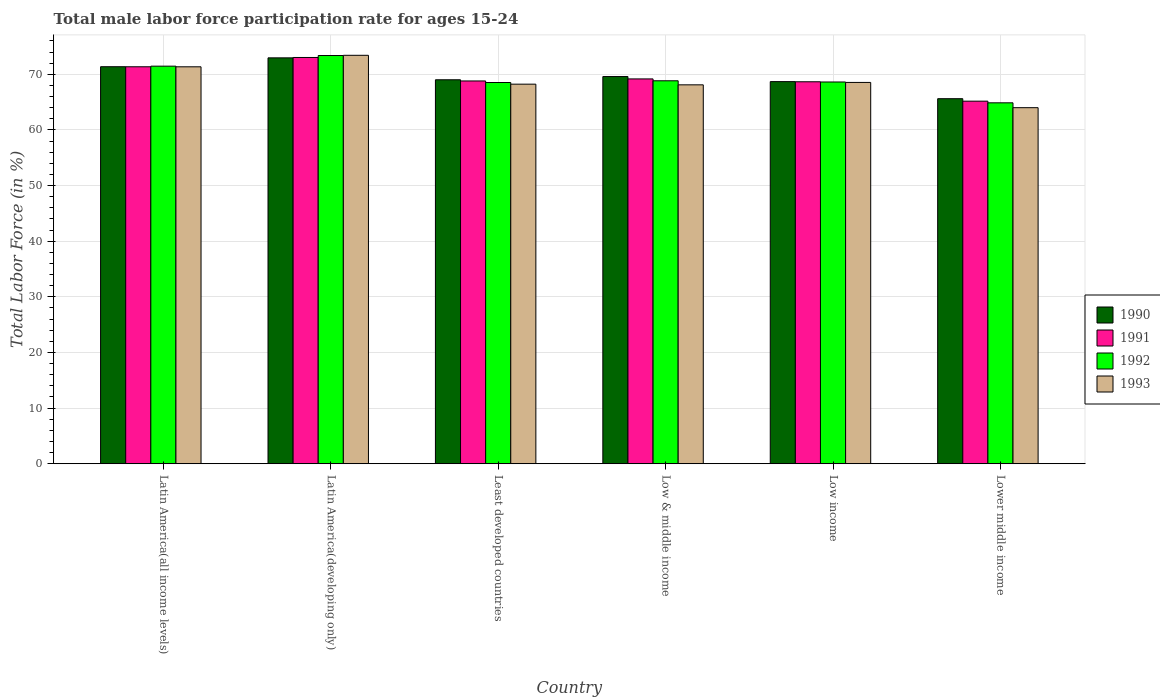How many groups of bars are there?
Give a very brief answer. 6. Are the number of bars per tick equal to the number of legend labels?
Keep it short and to the point. Yes. How many bars are there on the 4th tick from the right?
Your answer should be very brief. 4. In how many cases, is the number of bars for a given country not equal to the number of legend labels?
Your answer should be compact. 0. What is the male labor force participation rate in 1991 in Least developed countries?
Make the answer very short. 68.8. Across all countries, what is the maximum male labor force participation rate in 1993?
Ensure brevity in your answer.  73.42. Across all countries, what is the minimum male labor force participation rate in 1993?
Give a very brief answer. 64. In which country was the male labor force participation rate in 1992 maximum?
Keep it short and to the point. Latin America(developing only). In which country was the male labor force participation rate in 1992 minimum?
Make the answer very short. Lower middle income. What is the total male labor force participation rate in 1991 in the graph?
Offer a terse response. 416.18. What is the difference between the male labor force participation rate in 1993 in Latin America(developing only) and that in Low & middle income?
Make the answer very short. 5.31. What is the difference between the male labor force participation rate in 1991 in Low & middle income and the male labor force participation rate in 1992 in Latin America(developing only)?
Your answer should be compact. -4.21. What is the average male labor force participation rate in 1991 per country?
Keep it short and to the point. 69.36. What is the difference between the male labor force participation rate of/in 1992 and male labor force participation rate of/in 1993 in Least developed countries?
Your answer should be very brief. 0.3. What is the ratio of the male labor force participation rate in 1991 in Latin America(developing only) to that in Low income?
Provide a succinct answer. 1.06. What is the difference between the highest and the second highest male labor force participation rate in 1990?
Provide a short and direct response. 3.36. What is the difference between the highest and the lowest male labor force participation rate in 1990?
Offer a terse response. 7.34. Is the sum of the male labor force participation rate in 1993 in Latin America(all income levels) and Low & middle income greater than the maximum male labor force participation rate in 1990 across all countries?
Your answer should be compact. Yes. Is it the case that in every country, the sum of the male labor force participation rate in 1992 and male labor force participation rate in 1993 is greater than the sum of male labor force participation rate in 1990 and male labor force participation rate in 1991?
Provide a succinct answer. No. What does the 3rd bar from the left in Latin America(developing only) represents?
Your answer should be very brief. 1992. How many countries are there in the graph?
Your answer should be very brief. 6. What is the difference between two consecutive major ticks on the Y-axis?
Ensure brevity in your answer.  10. Does the graph contain any zero values?
Offer a terse response. No. Where does the legend appear in the graph?
Provide a short and direct response. Center right. What is the title of the graph?
Your answer should be compact. Total male labor force participation rate for ages 15-24. What is the label or title of the X-axis?
Your answer should be very brief. Country. What is the label or title of the Y-axis?
Make the answer very short. Total Labor Force (in %). What is the Total Labor Force (in %) in 1990 in Latin America(all income levels)?
Offer a very short reply. 71.36. What is the Total Labor Force (in %) in 1991 in Latin America(all income levels)?
Make the answer very short. 71.35. What is the Total Labor Force (in %) of 1992 in Latin America(all income levels)?
Keep it short and to the point. 71.46. What is the Total Labor Force (in %) in 1993 in Latin America(all income levels)?
Provide a succinct answer. 71.35. What is the Total Labor Force (in %) in 1990 in Latin America(developing only)?
Your response must be concise. 72.96. What is the Total Labor Force (in %) in 1991 in Latin America(developing only)?
Your answer should be compact. 73.02. What is the Total Labor Force (in %) in 1992 in Latin America(developing only)?
Your response must be concise. 73.38. What is the Total Labor Force (in %) in 1993 in Latin America(developing only)?
Give a very brief answer. 73.42. What is the Total Labor Force (in %) of 1990 in Least developed countries?
Your answer should be compact. 69.02. What is the Total Labor Force (in %) of 1991 in Least developed countries?
Ensure brevity in your answer.  68.8. What is the Total Labor Force (in %) in 1992 in Least developed countries?
Provide a short and direct response. 68.53. What is the Total Labor Force (in %) in 1993 in Least developed countries?
Your response must be concise. 68.23. What is the Total Labor Force (in %) of 1990 in Low & middle income?
Your answer should be compact. 69.59. What is the Total Labor Force (in %) in 1991 in Low & middle income?
Offer a terse response. 69.17. What is the Total Labor Force (in %) in 1992 in Low & middle income?
Provide a succinct answer. 68.83. What is the Total Labor Force (in %) in 1993 in Low & middle income?
Provide a short and direct response. 68.11. What is the Total Labor Force (in %) of 1990 in Low income?
Your response must be concise. 68.69. What is the Total Labor Force (in %) of 1991 in Low income?
Ensure brevity in your answer.  68.66. What is the Total Labor Force (in %) in 1992 in Low income?
Give a very brief answer. 68.62. What is the Total Labor Force (in %) of 1993 in Low income?
Offer a terse response. 68.54. What is the Total Labor Force (in %) in 1990 in Lower middle income?
Your answer should be compact. 65.62. What is the Total Labor Force (in %) in 1991 in Lower middle income?
Offer a terse response. 65.17. What is the Total Labor Force (in %) in 1992 in Lower middle income?
Provide a succinct answer. 64.87. What is the Total Labor Force (in %) in 1993 in Lower middle income?
Your response must be concise. 64. Across all countries, what is the maximum Total Labor Force (in %) in 1990?
Ensure brevity in your answer.  72.96. Across all countries, what is the maximum Total Labor Force (in %) of 1991?
Make the answer very short. 73.02. Across all countries, what is the maximum Total Labor Force (in %) in 1992?
Provide a succinct answer. 73.38. Across all countries, what is the maximum Total Labor Force (in %) in 1993?
Offer a very short reply. 73.42. Across all countries, what is the minimum Total Labor Force (in %) in 1990?
Offer a very short reply. 65.62. Across all countries, what is the minimum Total Labor Force (in %) of 1991?
Ensure brevity in your answer.  65.17. Across all countries, what is the minimum Total Labor Force (in %) of 1992?
Your answer should be compact. 64.87. Across all countries, what is the minimum Total Labor Force (in %) of 1993?
Your answer should be very brief. 64. What is the total Total Labor Force (in %) of 1990 in the graph?
Your answer should be very brief. 417.24. What is the total Total Labor Force (in %) of 1991 in the graph?
Your answer should be very brief. 416.18. What is the total Total Labor Force (in %) in 1992 in the graph?
Offer a very short reply. 415.69. What is the total Total Labor Force (in %) of 1993 in the graph?
Your response must be concise. 413.64. What is the difference between the Total Labor Force (in %) in 1990 in Latin America(all income levels) and that in Latin America(developing only)?
Your answer should be very brief. -1.59. What is the difference between the Total Labor Force (in %) of 1991 in Latin America(all income levels) and that in Latin America(developing only)?
Make the answer very short. -1.67. What is the difference between the Total Labor Force (in %) in 1992 in Latin America(all income levels) and that in Latin America(developing only)?
Make the answer very short. -1.91. What is the difference between the Total Labor Force (in %) of 1993 in Latin America(all income levels) and that in Latin America(developing only)?
Ensure brevity in your answer.  -2.07. What is the difference between the Total Labor Force (in %) in 1990 in Latin America(all income levels) and that in Least developed countries?
Ensure brevity in your answer.  2.35. What is the difference between the Total Labor Force (in %) of 1991 in Latin America(all income levels) and that in Least developed countries?
Your answer should be compact. 2.55. What is the difference between the Total Labor Force (in %) of 1992 in Latin America(all income levels) and that in Least developed countries?
Your answer should be compact. 2.94. What is the difference between the Total Labor Force (in %) in 1993 in Latin America(all income levels) and that in Least developed countries?
Provide a short and direct response. 3.12. What is the difference between the Total Labor Force (in %) of 1990 in Latin America(all income levels) and that in Low & middle income?
Your answer should be compact. 1.77. What is the difference between the Total Labor Force (in %) of 1991 in Latin America(all income levels) and that in Low & middle income?
Provide a succinct answer. 2.18. What is the difference between the Total Labor Force (in %) in 1992 in Latin America(all income levels) and that in Low & middle income?
Provide a succinct answer. 2.63. What is the difference between the Total Labor Force (in %) of 1993 in Latin America(all income levels) and that in Low & middle income?
Your answer should be compact. 3.24. What is the difference between the Total Labor Force (in %) of 1990 in Latin America(all income levels) and that in Low income?
Keep it short and to the point. 2.68. What is the difference between the Total Labor Force (in %) of 1991 in Latin America(all income levels) and that in Low income?
Give a very brief answer. 2.69. What is the difference between the Total Labor Force (in %) in 1992 in Latin America(all income levels) and that in Low income?
Your answer should be compact. 2.84. What is the difference between the Total Labor Force (in %) in 1993 in Latin America(all income levels) and that in Low income?
Make the answer very short. 2.81. What is the difference between the Total Labor Force (in %) in 1990 in Latin America(all income levels) and that in Lower middle income?
Offer a very short reply. 5.75. What is the difference between the Total Labor Force (in %) of 1991 in Latin America(all income levels) and that in Lower middle income?
Your answer should be compact. 6.18. What is the difference between the Total Labor Force (in %) of 1992 in Latin America(all income levels) and that in Lower middle income?
Your answer should be compact. 6.59. What is the difference between the Total Labor Force (in %) of 1993 in Latin America(all income levels) and that in Lower middle income?
Keep it short and to the point. 7.35. What is the difference between the Total Labor Force (in %) in 1990 in Latin America(developing only) and that in Least developed countries?
Your response must be concise. 3.94. What is the difference between the Total Labor Force (in %) in 1991 in Latin America(developing only) and that in Least developed countries?
Provide a succinct answer. 4.22. What is the difference between the Total Labor Force (in %) of 1992 in Latin America(developing only) and that in Least developed countries?
Offer a very short reply. 4.85. What is the difference between the Total Labor Force (in %) in 1993 in Latin America(developing only) and that in Least developed countries?
Your answer should be very brief. 5.19. What is the difference between the Total Labor Force (in %) in 1990 in Latin America(developing only) and that in Low & middle income?
Offer a terse response. 3.36. What is the difference between the Total Labor Force (in %) of 1991 in Latin America(developing only) and that in Low & middle income?
Your response must be concise. 3.85. What is the difference between the Total Labor Force (in %) of 1992 in Latin America(developing only) and that in Low & middle income?
Offer a very short reply. 4.54. What is the difference between the Total Labor Force (in %) of 1993 in Latin America(developing only) and that in Low & middle income?
Provide a short and direct response. 5.31. What is the difference between the Total Labor Force (in %) of 1990 in Latin America(developing only) and that in Low income?
Provide a short and direct response. 4.27. What is the difference between the Total Labor Force (in %) in 1991 in Latin America(developing only) and that in Low income?
Ensure brevity in your answer.  4.37. What is the difference between the Total Labor Force (in %) of 1992 in Latin America(developing only) and that in Low income?
Provide a short and direct response. 4.76. What is the difference between the Total Labor Force (in %) in 1993 in Latin America(developing only) and that in Low income?
Your response must be concise. 4.88. What is the difference between the Total Labor Force (in %) in 1990 in Latin America(developing only) and that in Lower middle income?
Give a very brief answer. 7.34. What is the difference between the Total Labor Force (in %) of 1991 in Latin America(developing only) and that in Lower middle income?
Your response must be concise. 7.85. What is the difference between the Total Labor Force (in %) in 1992 in Latin America(developing only) and that in Lower middle income?
Give a very brief answer. 8.5. What is the difference between the Total Labor Force (in %) in 1993 in Latin America(developing only) and that in Lower middle income?
Your answer should be compact. 9.42. What is the difference between the Total Labor Force (in %) of 1990 in Least developed countries and that in Low & middle income?
Make the answer very short. -0.58. What is the difference between the Total Labor Force (in %) of 1991 in Least developed countries and that in Low & middle income?
Make the answer very short. -0.37. What is the difference between the Total Labor Force (in %) in 1992 in Least developed countries and that in Low & middle income?
Offer a very short reply. -0.31. What is the difference between the Total Labor Force (in %) in 1993 in Least developed countries and that in Low & middle income?
Ensure brevity in your answer.  0.12. What is the difference between the Total Labor Force (in %) in 1990 in Least developed countries and that in Low income?
Provide a succinct answer. 0.33. What is the difference between the Total Labor Force (in %) of 1991 in Least developed countries and that in Low income?
Your answer should be very brief. 0.14. What is the difference between the Total Labor Force (in %) in 1992 in Least developed countries and that in Low income?
Provide a short and direct response. -0.09. What is the difference between the Total Labor Force (in %) of 1993 in Least developed countries and that in Low income?
Provide a short and direct response. -0.31. What is the difference between the Total Labor Force (in %) in 1990 in Least developed countries and that in Lower middle income?
Offer a terse response. 3.4. What is the difference between the Total Labor Force (in %) in 1991 in Least developed countries and that in Lower middle income?
Your answer should be compact. 3.63. What is the difference between the Total Labor Force (in %) of 1992 in Least developed countries and that in Lower middle income?
Provide a short and direct response. 3.65. What is the difference between the Total Labor Force (in %) in 1993 in Least developed countries and that in Lower middle income?
Offer a very short reply. 4.23. What is the difference between the Total Labor Force (in %) of 1990 in Low & middle income and that in Low income?
Your response must be concise. 0.91. What is the difference between the Total Labor Force (in %) in 1991 in Low & middle income and that in Low income?
Give a very brief answer. 0.51. What is the difference between the Total Labor Force (in %) of 1992 in Low & middle income and that in Low income?
Make the answer very short. 0.22. What is the difference between the Total Labor Force (in %) of 1993 in Low & middle income and that in Low income?
Your response must be concise. -0.43. What is the difference between the Total Labor Force (in %) of 1990 in Low & middle income and that in Lower middle income?
Your response must be concise. 3.98. What is the difference between the Total Labor Force (in %) in 1991 in Low & middle income and that in Lower middle income?
Make the answer very short. 4. What is the difference between the Total Labor Force (in %) of 1992 in Low & middle income and that in Lower middle income?
Offer a very short reply. 3.96. What is the difference between the Total Labor Force (in %) in 1993 in Low & middle income and that in Lower middle income?
Offer a very short reply. 4.11. What is the difference between the Total Labor Force (in %) of 1990 in Low income and that in Lower middle income?
Offer a very short reply. 3.07. What is the difference between the Total Labor Force (in %) of 1991 in Low income and that in Lower middle income?
Your answer should be very brief. 3.49. What is the difference between the Total Labor Force (in %) in 1992 in Low income and that in Lower middle income?
Give a very brief answer. 3.74. What is the difference between the Total Labor Force (in %) of 1993 in Low income and that in Lower middle income?
Offer a terse response. 4.54. What is the difference between the Total Labor Force (in %) of 1990 in Latin America(all income levels) and the Total Labor Force (in %) of 1991 in Latin America(developing only)?
Your answer should be compact. -1.66. What is the difference between the Total Labor Force (in %) in 1990 in Latin America(all income levels) and the Total Labor Force (in %) in 1992 in Latin America(developing only)?
Provide a short and direct response. -2.01. What is the difference between the Total Labor Force (in %) in 1990 in Latin America(all income levels) and the Total Labor Force (in %) in 1993 in Latin America(developing only)?
Give a very brief answer. -2.05. What is the difference between the Total Labor Force (in %) in 1991 in Latin America(all income levels) and the Total Labor Force (in %) in 1992 in Latin America(developing only)?
Your answer should be very brief. -2.02. What is the difference between the Total Labor Force (in %) in 1991 in Latin America(all income levels) and the Total Labor Force (in %) in 1993 in Latin America(developing only)?
Keep it short and to the point. -2.06. What is the difference between the Total Labor Force (in %) of 1992 in Latin America(all income levels) and the Total Labor Force (in %) of 1993 in Latin America(developing only)?
Give a very brief answer. -1.95. What is the difference between the Total Labor Force (in %) in 1990 in Latin America(all income levels) and the Total Labor Force (in %) in 1991 in Least developed countries?
Provide a short and direct response. 2.56. What is the difference between the Total Labor Force (in %) in 1990 in Latin America(all income levels) and the Total Labor Force (in %) in 1992 in Least developed countries?
Your answer should be compact. 2.84. What is the difference between the Total Labor Force (in %) in 1990 in Latin America(all income levels) and the Total Labor Force (in %) in 1993 in Least developed countries?
Your response must be concise. 3.14. What is the difference between the Total Labor Force (in %) in 1991 in Latin America(all income levels) and the Total Labor Force (in %) in 1992 in Least developed countries?
Provide a short and direct response. 2.83. What is the difference between the Total Labor Force (in %) in 1991 in Latin America(all income levels) and the Total Labor Force (in %) in 1993 in Least developed countries?
Provide a succinct answer. 3.12. What is the difference between the Total Labor Force (in %) in 1992 in Latin America(all income levels) and the Total Labor Force (in %) in 1993 in Least developed countries?
Keep it short and to the point. 3.23. What is the difference between the Total Labor Force (in %) in 1990 in Latin America(all income levels) and the Total Labor Force (in %) in 1991 in Low & middle income?
Offer a terse response. 2.19. What is the difference between the Total Labor Force (in %) in 1990 in Latin America(all income levels) and the Total Labor Force (in %) in 1992 in Low & middle income?
Provide a succinct answer. 2.53. What is the difference between the Total Labor Force (in %) of 1990 in Latin America(all income levels) and the Total Labor Force (in %) of 1993 in Low & middle income?
Your answer should be compact. 3.26. What is the difference between the Total Labor Force (in %) in 1991 in Latin America(all income levels) and the Total Labor Force (in %) in 1992 in Low & middle income?
Your answer should be compact. 2.52. What is the difference between the Total Labor Force (in %) in 1991 in Latin America(all income levels) and the Total Labor Force (in %) in 1993 in Low & middle income?
Make the answer very short. 3.25. What is the difference between the Total Labor Force (in %) in 1992 in Latin America(all income levels) and the Total Labor Force (in %) in 1993 in Low & middle income?
Your answer should be compact. 3.36. What is the difference between the Total Labor Force (in %) in 1990 in Latin America(all income levels) and the Total Labor Force (in %) in 1991 in Low income?
Your response must be concise. 2.71. What is the difference between the Total Labor Force (in %) in 1990 in Latin America(all income levels) and the Total Labor Force (in %) in 1992 in Low income?
Offer a very short reply. 2.75. What is the difference between the Total Labor Force (in %) in 1990 in Latin America(all income levels) and the Total Labor Force (in %) in 1993 in Low income?
Your response must be concise. 2.82. What is the difference between the Total Labor Force (in %) of 1991 in Latin America(all income levels) and the Total Labor Force (in %) of 1992 in Low income?
Keep it short and to the point. 2.73. What is the difference between the Total Labor Force (in %) in 1991 in Latin America(all income levels) and the Total Labor Force (in %) in 1993 in Low income?
Your answer should be compact. 2.81. What is the difference between the Total Labor Force (in %) in 1992 in Latin America(all income levels) and the Total Labor Force (in %) in 1993 in Low income?
Make the answer very short. 2.92. What is the difference between the Total Labor Force (in %) in 1990 in Latin America(all income levels) and the Total Labor Force (in %) in 1991 in Lower middle income?
Your answer should be very brief. 6.19. What is the difference between the Total Labor Force (in %) in 1990 in Latin America(all income levels) and the Total Labor Force (in %) in 1992 in Lower middle income?
Make the answer very short. 6.49. What is the difference between the Total Labor Force (in %) of 1990 in Latin America(all income levels) and the Total Labor Force (in %) of 1993 in Lower middle income?
Your answer should be compact. 7.36. What is the difference between the Total Labor Force (in %) in 1991 in Latin America(all income levels) and the Total Labor Force (in %) in 1992 in Lower middle income?
Ensure brevity in your answer.  6.48. What is the difference between the Total Labor Force (in %) of 1991 in Latin America(all income levels) and the Total Labor Force (in %) of 1993 in Lower middle income?
Give a very brief answer. 7.35. What is the difference between the Total Labor Force (in %) of 1992 in Latin America(all income levels) and the Total Labor Force (in %) of 1993 in Lower middle income?
Your answer should be compact. 7.46. What is the difference between the Total Labor Force (in %) of 1990 in Latin America(developing only) and the Total Labor Force (in %) of 1991 in Least developed countries?
Offer a very short reply. 4.15. What is the difference between the Total Labor Force (in %) of 1990 in Latin America(developing only) and the Total Labor Force (in %) of 1992 in Least developed countries?
Give a very brief answer. 4.43. What is the difference between the Total Labor Force (in %) of 1990 in Latin America(developing only) and the Total Labor Force (in %) of 1993 in Least developed countries?
Offer a very short reply. 4.73. What is the difference between the Total Labor Force (in %) in 1991 in Latin America(developing only) and the Total Labor Force (in %) in 1992 in Least developed countries?
Your response must be concise. 4.5. What is the difference between the Total Labor Force (in %) of 1991 in Latin America(developing only) and the Total Labor Force (in %) of 1993 in Least developed countries?
Provide a succinct answer. 4.8. What is the difference between the Total Labor Force (in %) of 1992 in Latin America(developing only) and the Total Labor Force (in %) of 1993 in Least developed countries?
Offer a very short reply. 5.15. What is the difference between the Total Labor Force (in %) of 1990 in Latin America(developing only) and the Total Labor Force (in %) of 1991 in Low & middle income?
Ensure brevity in your answer.  3.79. What is the difference between the Total Labor Force (in %) of 1990 in Latin America(developing only) and the Total Labor Force (in %) of 1992 in Low & middle income?
Ensure brevity in your answer.  4.12. What is the difference between the Total Labor Force (in %) in 1990 in Latin America(developing only) and the Total Labor Force (in %) in 1993 in Low & middle income?
Give a very brief answer. 4.85. What is the difference between the Total Labor Force (in %) of 1991 in Latin America(developing only) and the Total Labor Force (in %) of 1992 in Low & middle income?
Provide a short and direct response. 4.19. What is the difference between the Total Labor Force (in %) of 1991 in Latin America(developing only) and the Total Labor Force (in %) of 1993 in Low & middle income?
Offer a terse response. 4.92. What is the difference between the Total Labor Force (in %) of 1992 in Latin America(developing only) and the Total Labor Force (in %) of 1993 in Low & middle income?
Provide a succinct answer. 5.27. What is the difference between the Total Labor Force (in %) in 1990 in Latin America(developing only) and the Total Labor Force (in %) in 1991 in Low income?
Your answer should be compact. 4.3. What is the difference between the Total Labor Force (in %) of 1990 in Latin America(developing only) and the Total Labor Force (in %) of 1992 in Low income?
Offer a terse response. 4.34. What is the difference between the Total Labor Force (in %) in 1990 in Latin America(developing only) and the Total Labor Force (in %) in 1993 in Low income?
Make the answer very short. 4.42. What is the difference between the Total Labor Force (in %) in 1991 in Latin America(developing only) and the Total Labor Force (in %) in 1992 in Low income?
Give a very brief answer. 4.4. What is the difference between the Total Labor Force (in %) of 1991 in Latin America(developing only) and the Total Labor Force (in %) of 1993 in Low income?
Your answer should be compact. 4.48. What is the difference between the Total Labor Force (in %) in 1992 in Latin America(developing only) and the Total Labor Force (in %) in 1993 in Low income?
Your answer should be very brief. 4.83. What is the difference between the Total Labor Force (in %) in 1990 in Latin America(developing only) and the Total Labor Force (in %) in 1991 in Lower middle income?
Ensure brevity in your answer.  7.79. What is the difference between the Total Labor Force (in %) of 1990 in Latin America(developing only) and the Total Labor Force (in %) of 1992 in Lower middle income?
Offer a very short reply. 8.08. What is the difference between the Total Labor Force (in %) in 1990 in Latin America(developing only) and the Total Labor Force (in %) in 1993 in Lower middle income?
Your answer should be very brief. 8.96. What is the difference between the Total Labor Force (in %) in 1991 in Latin America(developing only) and the Total Labor Force (in %) in 1992 in Lower middle income?
Make the answer very short. 8.15. What is the difference between the Total Labor Force (in %) of 1991 in Latin America(developing only) and the Total Labor Force (in %) of 1993 in Lower middle income?
Your answer should be compact. 9.02. What is the difference between the Total Labor Force (in %) of 1992 in Latin America(developing only) and the Total Labor Force (in %) of 1993 in Lower middle income?
Provide a succinct answer. 9.37. What is the difference between the Total Labor Force (in %) in 1990 in Least developed countries and the Total Labor Force (in %) in 1991 in Low & middle income?
Offer a very short reply. -0.15. What is the difference between the Total Labor Force (in %) of 1990 in Least developed countries and the Total Labor Force (in %) of 1992 in Low & middle income?
Keep it short and to the point. 0.18. What is the difference between the Total Labor Force (in %) in 1990 in Least developed countries and the Total Labor Force (in %) in 1993 in Low & middle income?
Ensure brevity in your answer.  0.91. What is the difference between the Total Labor Force (in %) of 1991 in Least developed countries and the Total Labor Force (in %) of 1992 in Low & middle income?
Ensure brevity in your answer.  -0.03. What is the difference between the Total Labor Force (in %) in 1991 in Least developed countries and the Total Labor Force (in %) in 1993 in Low & middle income?
Keep it short and to the point. 0.7. What is the difference between the Total Labor Force (in %) of 1992 in Least developed countries and the Total Labor Force (in %) of 1993 in Low & middle income?
Offer a very short reply. 0.42. What is the difference between the Total Labor Force (in %) of 1990 in Least developed countries and the Total Labor Force (in %) of 1991 in Low income?
Give a very brief answer. 0.36. What is the difference between the Total Labor Force (in %) in 1990 in Least developed countries and the Total Labor Force (in %) in 1992 in Low income?
Provide a short and direct response. 0.4. What is the difference between the Total Labor Force (in %) of 1990 in Least developed countries and the Total Labor Force (in %) of 1993 in Low income?
Keep it short and to the point. 0.48. What is the difference between the Total Labor Force (in %) in 1991 in Least developed countries and the Total Labor Force (in %) in 1992 in Low income?
Give a very brief answer. 0.18. What is the difference between the Total Labor Force (in %) of 1991 in Least developed countries and the Total Labor Force (in %) of 1993 in Low income?
Offer a very short reply. 0.26. What is the difference between the Total Labor Force (in %) of 1992 in Least developed countries and the Total Labor Force (in %) of 1993 in Low income?
Keep it short and to the point. -0.01. What is the difference between the Total Labor Force (in %) in 1990 in Least developed countries and the Total Labor Force (in %) in 1991 in Lower middle income?
Offer a terse response. 3.85. What is the difference between the Total Labor Force (in %) in 1990 in Least developed countries and the Total Labor Force (in %) in 1992 in Lower middle income?
Give a very brief answer. 4.14. What is the difference between the Total Labor Force (in %) of 1990 in Least developed countries and the Total Labor Force (in %) of 1993 in Lower middle income?
Your response must be concise. 5.02. What is the difference between the Total Labor Force (in %) of 1991 in Least developed countries and the Total Labor Force (in %) of 1992 in Lower middle income?
Provide a succinct answer. 3.93. What is the difference between the Total Labor Force (in %) in 1991 in Least developed countries and the Total Labor Force (in %) in 1993 in Lower middle income?
Your answer should be compact. 4.8. What is the difference between the Total Labor Force (in %) in 1992 in Least developed countries and the Total Labor Force (in %) in 1993 in Lower middle income?
Your answer should be compact. 4.53. What is the difference between the Total Labor Force (in %) in 1990 in Low & middle income and the Total Labor Force (in %) in 1991 in Low income?
Your answer should be very brief. 0.94. What is the difference between the Total Labor Force (in %) in 1990 in Low & middle income and the Total Labor Force (in %) in 1992 in Low income?
Give a very brief answer. 0.98. What is the difference between the Total Labor Force (in %) in 1990 in Low & middle income and the Total Labor Force (in %) in 1993 in Low income?
Ensure brevity in your answer.  1.05. What is the difference between the Total Labor Force (in %) of 1991 in Low & middle income and the Total Labor Force (in %) of 1992 in Low income?
Provide a short and direct response. 0.55. What is the difference between the Total Labor Force (in %) of 1991 in Low & middle income and the Total Labor Force (in %) of 1993 in Low income?
Provide a succinct answer. 0.63. What is the difference between the Total Labor Force (in %) of 1992 in Low & middle income and the Total Labor Force (in %) of 1993 in Low income?
Provide a short and direct response. 0.29. What is the difference between the Total Labor Force (in %) in 1990 in Low & middle income and the Total Labor Force (in %) in 1991 in Lower middle income?
Your answer should be very brief. 4.42. What is the difference between the Total Labor Force (in %) of 1990 in Low & middle income and the Total Labor Force (in %) of 1992 in Lower middle income?
Your answer should be very brief. 4.72. What is the difference between the Total Labor Force (in %) of 1990 in Low & middle income and the Total Labor Force (in %) of 1993 in Lower middle income?
Your answer should be compact. 5.59. What is the difference between the Total Labor Force (in %) of 1991 in Low & middle income and the Total Labor Force (in %) of 1992 in Lower middle income?
Make the answer very short. 4.3. What is the difference between the Total Labor Force (in %) of 1991 in Low & middle income and the Total Labor Force (in %) of 1993 in Lower middle income?
Offer a terse response. 5.17. What is the difference between the Total Labor Force (in %) in 1992 in Low & middle income and the Total Labor Force (in %) in 1993 in Lower middle income?
Your response must be concise. 4.83. What is the difference between the Total Labor Force (in %) of 1990 in Low income and the Total Labor Force (in %) of 1991 in Lower middle income?
Keep it short and to the point. 3.51. What is the difference between the Total Labor Force (in %) in 1990 in Low income and the Total Labor Force (in %) in 1992 in Lower middle income?
Provide a succinct answer. 3.81. What is the difference between the Total Labor Force (in %) in 1990 in Low income and the Total Labor Force (in %) in 1993 in Lower middle income?
Your answer should be very brief. 4.68. What is the difference between the Total Labor Force (in %) in 1991 in Low income and the Total Labor Force (in %) in 1992 in Lower middle income?
Give a very brief answer. 3.78. What is the difference between the Total Labor Force (in %) of 1991 in Low income and the Total Labor Force (in %) of 1993 in Lower middle income?
Ensure brevity in your answer.  4.66. What is the difference between the Total Labor Force (in %) in 1992 in Low income and the Total Labor Force (in %) in 1993 in Lower middle income?
Ensure brevity in your answer.  4.62. What is the average Total Labor Force (in %) of 1990 per country?
Make the answer very short. 69.54. What is the average Total Labor Force (in %) of 1991 per country?
Your answer should be compact. 69.36. What is the average Total Labor Force (in %) in 1992 per country?
Provide a short and direct response. 69.28. What is the average Total Labor Force (in %) in 1993 per country?
Provide a succinct answer. 68.94. What is the difference between the Total Labor Force (in %) of 1990 and Total Labor Force (in %) of 1991 in Latin America(all income levels)?
Provide a short and direct response. 0.01. What is the difference between the Total Labor Force (in %) of 1990 and Total Labor Force (in %) of 1992 in Latin America(all income levels)?
Your answer should be very brief. -0.1. What is the difference between the Total Labor Force (in %) of 1990 and Total Labor Force (in %) of 1993 in Latin America(all income levels)?
Offer a very short reply. 0.02. What is the difference between the Total Labor Force (in %) of 1991 and Total Labor Force (in %) of 1992 in Latin America(all income levels)?
Offer a very short reply. -0.11. What is the difference between the Total Labor Force (in %) of 1991 and Total Labor Force (in %) of 1993 in Latin America(all income levels)?
Your answer should be very brief. 0. What is the difference between the Total Labor Force (in %) in 1992 and Total Labor Force (in %) in 1993 in Latin America(all income levels)?
Provide a short and direct response. 0.11. What is the difference between the Total Labor Force (in %) of 1990 and Total Labor Force (in %) of 1991 in Latin America(developing only)?
Your answer should be compact. -0.07. What is the difference between the Total Labor Force (in %) of 1990 and Total Labor Force (in %) of 1992 in Latin America(developing only)?
Your response must be concise. -0.42. What is the difference between the Total Labor Force (in %) of 1990 and Total Labor Force (in %) of 1993 in Latin America(developing only)?
Offer a terse response. -0.46. What is the difference between the Total Labor Force (in %) of 1991 and Total Labor Force (in %) of 1992 in Latin America(developing only)?
Provide a short and direct response. -0.35. What is the difference between the Total Labor Force (in %) of 1991 and Total Labor Force (in %) of 1993 in Latin America(developing only)?
Give a very brief answer. -0.39. What is the difference between the Total Labor Force (in %) in 1992 and Total Labor Force (in %) in 1993 in Latin America(developing only)?
Make the answer very short. -0.04. What is the difference between the Total Labor Force (in %) in 1990 and Total Labor Force (in %) in 1991 in Least developed countries?
Give a very brief answer. 0.21. What is the difference between the Total Labor Force (in %) in 1990 and Total Labor Force (in %) in 1992 in Least developed countries?
Ensure brevity in your answer.  0.49. What is the difference between the Total Labor Force (in %) in 1990 and Total Labor Force (in %) in 1993 in Least developed countries?
Offer a terse response. 0.79. What is the difference between the Total Labor Force (in %) in 1991 and Total Labor Force (in %) in 1992 in Least developed countries?
Make the answer very short. 0.28. What is the difference between the Total Labor Force (in %) of 1991 and Total Labor Force (in %) of 1993 in Least developed countries?
Keep it short and to the point. 0.57. What is the difference between the Total Labor Force (in %) in 1992 and Total Labor Force (in %) in 1993 in Least developed countries?
Your answer should be compact. 0.3. What is the difference between the Total Labor Force (in %) of 1990 and Total Labor Force (in %) of 1991 in Low & middle income?
Offer a very short reply. 0.42. What is the difference between the Total Labor Force (in %) of 1990 and Total Labor Force (in %) of 1992 in Low & middle income?
Give a very brief answer. 0.76. What is the difference between the Total Labor Force (in %) in 1990 and Total Labor Force (in %) in 1993 in Low & middle income?
Keep it short and to the point. 1.49. What is the difference between the Total Labor Force (in %) of 1991 and Total Labor Force (in %) of 1992 in Low & middle income?
Your response must be concise. 0.34. What is the difference between the Total Labor Force (in %) in 1991 and Total Labor Force (in %) in 1993 in Low & middle income?
Give a very brief answer. 1.06. What is the difference between the Total Labor Force (in %) in 1992 and Total Labor Force (in %) in 1993 in Low & middle income?
Make the answer very short. 0.73. What is the difference between the Total Labor Force (in %) in 1990 and Total Labor Force (in %) in 1991 in Low income?
Ensure brevity in your answer.  0.03. What is the difference between the Total Labor Force (in %) of 1990 and Total Labor Force (in %) of 1992 in Low income?
Make the answer very short. 0.07. What is the difference between the Total Labor Force (in %) in 1990 and Total Labor Force (in %) in 1993 in Low income?
Your response must be concise. 0.14. What is the difference between the Total Labor Force (in %) in 1991 and Total Labor Force (in %) in 1992 in Low income?
Provide a short and direct response. 0.04. What is the difference between the Total Labor Force (in %) of 1991 and Total Labor Force (in %) of 1993 in Low income?
Provide a succinct answer. 0.12. What is the difference between the Total Labor Force (in %) in 1992 and Total Labor Force (in %) in 1993 in Low income?
Provide a short and direct response. 0.08. What is the difference between the Total Labor Force (in %) of 1990 and Total Labor Force (in %) of 1991 in Lower middle income?
Provide a short and direct response. 0.45. What is the difference between the Total Labor Force (in %) of 1990 and Total Labor Force (in %) of 1992 in Lower middle income?
Give a very brief answer. 0.74. What is the difference between the Total Labor Force (in %) in 1990 and Total Labor Force (in %) in 1993 in Lower middle income?
Offer a terse response. 1.62. What is the difference between the Total Labor Force (in %) of 1991 and Total Labor Force (in %) of 1992 in Lower middle income?
Provide a succinct answer. 0.3. What is the difference between the Total Labor Force (in %) of 1991 and Total Labor Force (in %) of 1993 in Lower middle income?
Ensure brevity in your answer.  1.17. What is the difference between the Total Labor Force (in %) in 1992 and Total Labor Force (in %) in 1993 in Lower middle income?
Provide a succinct answer. 0.87. What is the ratio of the Total Labor Force (in %) of 1990 in Latin America(all income levels) to that in Latin America(developing only)?
Offer a very short reply. 0.98. What is the ratio of the Total Labor Force (in %) of 1991 in Latin America(all income levels) to that in Latin America(developing only)?
Offer a terse response. 0.98. What is the ratio of the Total Labor Force (in %) of 1992 in Latin America(all income levels) to that in Latin America(developing only)?
Provide a succinct answer. 0.97. What is the ratio of the Total Labor Force (in %) of 1993 in Latin America(all income levels) to that in Latin America(developing only)?
Provide a short and direct response. 0.97. What is the ratio of the Total Labor Force (in %) of 1990 in Latin America(all income levels) to that in Least developed countries?
Provide a short and direct response. 1.03. What is the ratio of the Total Labor Force (in %) of 1991 in Latin America(all income levels) to that in Least developed countries?
Ensure brevity in your answer.  1.04. What is the ratio of the Total Labor Force (in %) of 1992 in Latin America(all income levels) to that in Least developed countries?
Ensure brevity in your answer.  1.04. What is the ratio of the Total Labor Force (in %) of 1993 in Latin America(all income levels) to that in Least developed countries?
Offer a very short reply. 1.05. What is the ratio of the Total Labor Force (in %) of 1990 in Latin America(all income levels) to that in Low & middle income?
Offer a terse response. 1.03. What is the ratio of the Total Labor Force (in %) in 1991 in Latin America(all income levels) to that in Low & middle income?
Provide a short and direct response. 1.03. What is the ratio of the Total Labor Force (in %) in 1992 in Latin America(all income levels) to that in Low & middle income?
Ensure brevity in your answer.  1.04. What is the ratio of the Total Labor Force (in %) of 1993 in Latin America(all income levels) to that in Low & middle income?
Keep it short and to the point. 1.05. What is the ratio of the Total Labor Force (in %) in 1990 in Latin America(all income levels) to that in Low income?
Provide a succinct answer. 1.04. What is the ratio of the Total Labor Force (in %) of 1991 in Latin America(all income levels) to that in Low income?
Give a very brief answer. 1.04. What is the ratio of the Total Labor Force (in %) in 1992 in Latin America(all income levels) to that in Low income?
Offer a terse response. 1.04. What is the ratio of the Total Labor Force (in %) in 1993 in Latin America(all income levels) to that in Low income?
Your answer should be very brief. 1.04. What is the ratio of the Total Labor Force (in %) in 1990 in Latin America(all income levels) to that in Lower middle income?
Your response must be concise. 1.09. What is the ratio of the Total Labor Force (in %) of 1991 in Latin America(all income levels) to that in Lower middle income?
Offer a terse response. 1.09. What is the ratio of the Total Labor Force (in %) of 1992 in Latin America(all income levels) to that in Lower middle income?
Offer a very short reply. 1.1. What is the ratio of the Total Labor Force (in %) in 1993 in Latin America(all income levels) to that in Lower middle income?
Offer a terse response. 1.11. What is the ratio of the Total Labor Force (in %) of 1990 in Latin America(developing only) to that in Least developed countries?
Your answer should be very brief. 1.06. What is the ratio of the Total Labor Force (in %) in 1991 in Latin America(developing only) to that in Least developed countries?
Your response must be concise. 1.06. What is the ratio of the Total Labor Force (in %) of 1992 in Latin America(developing only) to that in Least developed countries?
Give a very brief answer. 1.07. What is the ratio of the Total Labor Force (in %) of 1993 in Latin America(developing only) to that in Least developed countries?
Keep it short and to the point. 1.08. What is the ratio of the Total Labor Force (in %) in 1990 in Latin America(developing only) to that in Low & middle income?
Offer a very short reply. 1.05. What is the ratio of the Total Labor Force (in %) of 1991 in Latin America(developing only) to that in Low & middle income?
Provide a succinct answer. 1.06. What is the ratio of the Total Labor Force (in %) of 1992 in Latin America(developing only) to that in Low & middle income?
Ensure brevity in your answer.  1.07. What is the ratio of the Total Labor Force (in %) in 1993 in Latin America(developing only) to that in Low & middle income?
Provide a succinct answer. 1.08. What is the ratio of the Total Labor Force (in %) in 1990 in Latin America(developing only) to that in Low income?
Offer a terse response. 1.06. What is the ratio of the Total Labor Force (in %) in 1991 in Latin America(developing only) to that in Low income?
Offer a very short reply. 1.06. What is the ratio of the Total Labor Force (in %) of 1992 in Latin America(developing only) to that in Low income?
Offer a very short reply. 1.07. What is the ratio of the Total Labor Force (in %) of 1993 in Latin America(developing only) to that in Low income?
Your answer should be very brief. 1.07. What is the ratio of the Total Labor Force (in %) in 1990 in Latin America(developing only) to that in Lower middle income?
Give a very brief answer. 1.11. What is the ratio of the Total Labor Force (in %) of 1991 in Latin America(developing only) to that in Lower middle income?
Provide a short and direct response. 1.12. What is the ratio of the Total Labor Force (in %) in 1992 in Latin America(developing only) to that in Lower middle income?
Ensure brevity in your answer.  1.13. What is the ratio of the Total Labor Force (in %) in 1993 in Latin America(developing only) to that in Lower middle income?
Offer a terse response. 1.15. What is the ratio of the Total Labor Force (in %) of 1992 in Least developed countries to that in Low & middle income?
Ensure brevity in your answer.  1. What is the ratio of the Total Labor Force (in %) of 1993 in Least developed countries to that in Low & middle income?
Offer a terse response. 1. What is the ratio of the Total Labor Force (in %) of 1990 in Least developed countries to that in Low income?
Make the answer very short. 1. What is the ratio of the Total Labor Force (in %) of 1991 in Least developed countries to that in Low income?
Provide a succinct answer. 1. What is the ratio of the Total Labor Force (in %) of 1993 in Least developed countries to that in Low income?
Offer a very short reply. 1. What is the ratio of the Total Labor Force (in %) of 1990 in Least developed countries to that in Lower middle income?
Your answer should be compact. 1.05. What is the ratio of the Total Labor Force (in %) of 1991 in Least developed countries to that in Lower middle income?
Offer a very short reply. 1.06. What is the ratio of the Total Labor Force (in %) of 1992 in Least developed countries to that in Lower middle income?
Make the answer very short. 1.06. What is the ratio of the Total Labor Force (in %) of 1993 in Least developed countries to that in Lower middle income?
Provide a succinct answer. 1.07. What is the ratio of the Total Labor Force (in %) of 1990 in Low & middle income to that in Low income?
Keep it short and to the point. 1.01. What is the ratio of the Total Labor Force (in %) of 1991 in Low & middle income to that in Low income?
Provide a short and direct response. 1.01. What is the ratio of the Total Labor Force (in %) of 1992 in Low & middle income to that in Low income?
Keep it short and to the point. 1. What is the ratio of the Total Labor Force (in %) of 1990 in Low & middle income to that in Lower middle income?
Keep it short and to the point. 1.06. What is the ratio of the Total Labor Force (in %) of 1991 in Low & middle income to that in Lower middle income?
Your response must be concise. 1.06. What is the ratio of the Total Labor Force (in %) in 1992 in Low & middle income to that in Lower middle income?
Offer a terse response. 1.06. What is the ratio of the Total Labor Force (in %) in 1993 in Low & middle income to that in Lower middle income?
Provide a succinct answer. 1.06. What is the ratio of the Total Labor Force (in %) in 1990 in Low income to that in Lower middle income?
Make the answer very short. 1.05. What is the ratio of the Total Labor Force (in %) in 1991 in Low income to that in Lower middle income?
Provide a succinct answer. 1.05. What is the ratio of the Total Labor Force (in %) of 1992 in Low income to that in Lower middle income?
Provide a short and direct response. 1.06. What is the ratio of the Total Labor Force (in %) of 1993 in Low income to that in Lower middle income?
Make the answer very short. 1.07. What is the difference between the highest and the second highest Total Labor Force (in %) in 1990?
Offer a terse response. 1.59. What is the difference between the highest and the second highest Total Labor Force (in %) in 1991?
Keep it short and to the point. 1.67. What is the difference between the highest and the second highest Total Labor Force (in %) of 1992?
Make the answer very short. 1.91. What is the difference between the highest and the second highest Total Labor Force (in %) in 1993?
Provide a short and direct response. 2.07. What is the difference between the highest and the lowest Total Labor Force (in %) of 1990?
Your answer should be very brief. 7.34. What is the difference between the highest and the lowest Total Labor Force (in %) in 1991?
Offer a very short reply. 7.85. What is the difference between the highest and the lowest Total Labor Force (in %) of 1992?
Make the answer very short. 8.5. What is the difference between the highest and the lowest Total Labor Force (in %) of 1993?
Offer a very short reply. 9.42. 